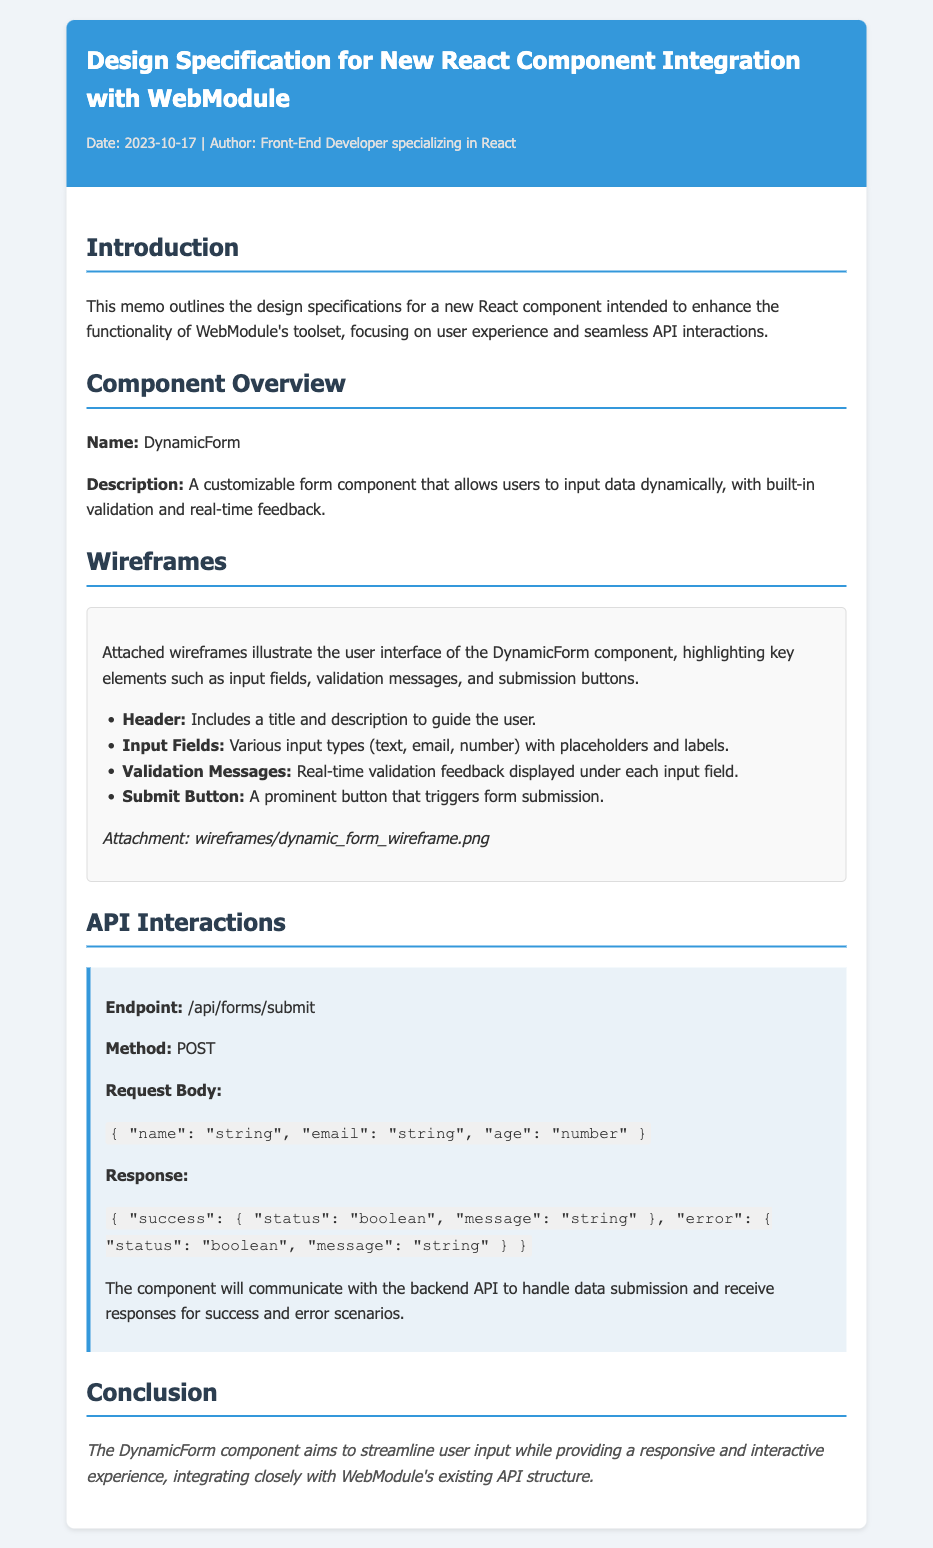What is the name of the new React component? The name of the new React component is specified in the document under Component Overview.
Answer: DynamicForm What is the submission API endpoint? The API endpoint for the form submission is mentioned in the API Interactions section.
Answer: /api/forms/submit What type of feedback does the DynamicForm provide? The document states that the component includes built-in validation and real-time feedback, implying user experience enhancements.
Answer: Real-time feedback What are the included input types in the DynamicForm? The wireframes section lists the various input types covered in the design specification.
Answer: Text, email, number What is the purpose of the DynamicForm component? The introduction outlines the main purpose of the component, focusing on enhancing functionality and user experience within WebModule.
Answer: Enhance functionality How does the component inform users of validation errors? The document specifies the presence of validation messages displayed under each input field in the wireframes section.
Answer: Under each input field What method is used to submit the form? The API section describes the method used for form submission, which is common in API documentation.
Answer: POST What date was this design specification authored? The date of authorship for the memo is included in the header meta section, indicating when it was created.
Answer: 2023-10-17 What is the author's specialization? The meta section of the header provides insight into the author's role and expertise related to the document.
Answer: Front-End Developer specializing in React 